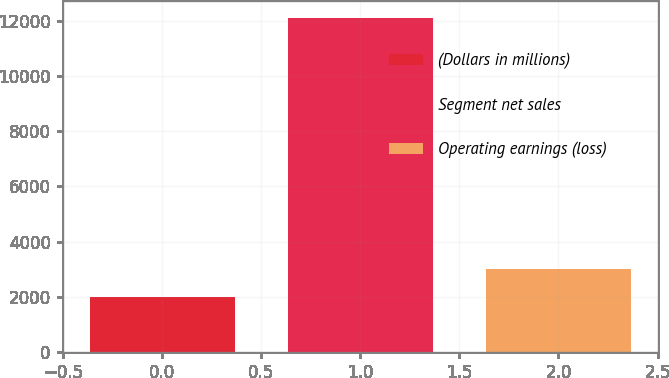Convert chart to OTSL. <chart><loc_0><loc_0><loc_500><loc_500><bar_chart><fcel>(Dollars in millions)<fcel>Segment net sales<fcel>Operating earnings (loss)<nl><fcel>2008<fcel>12099<fcel>3017.1<nl></chart> 